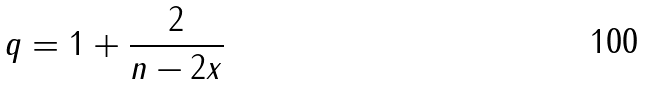Convert formula to latex. <formula><loc_0><loc_0><loc_500><loc_500>q = 1 + \frac { 2 } { n - 2 x }</formula> 